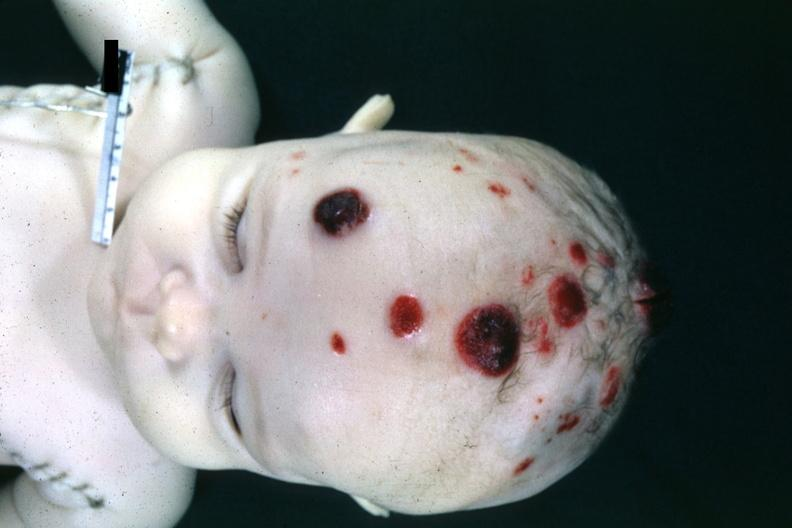what are in this file?
Answer the question using a single word or phrase. 4 month old child several slides from case 